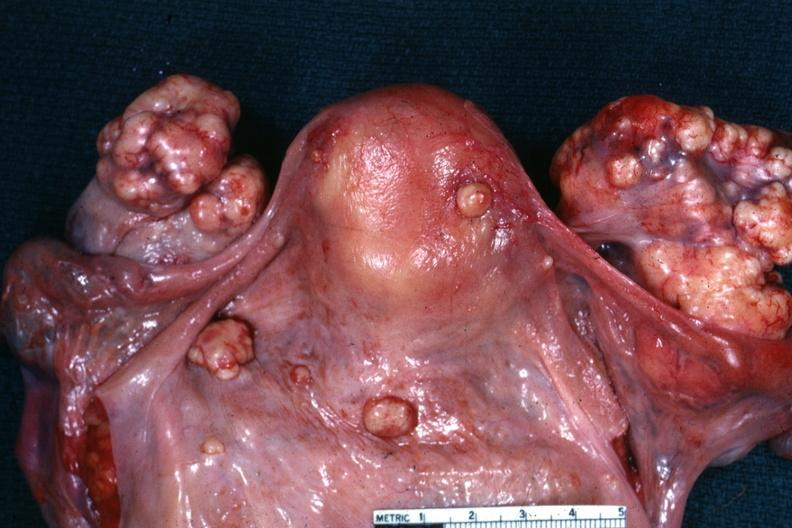was peritoneal surface of uterus and douglas pouch outstanding photo primary in the stomach this is true bilateral krukenberg?
Answer the question using a single word or phrase. Yes 